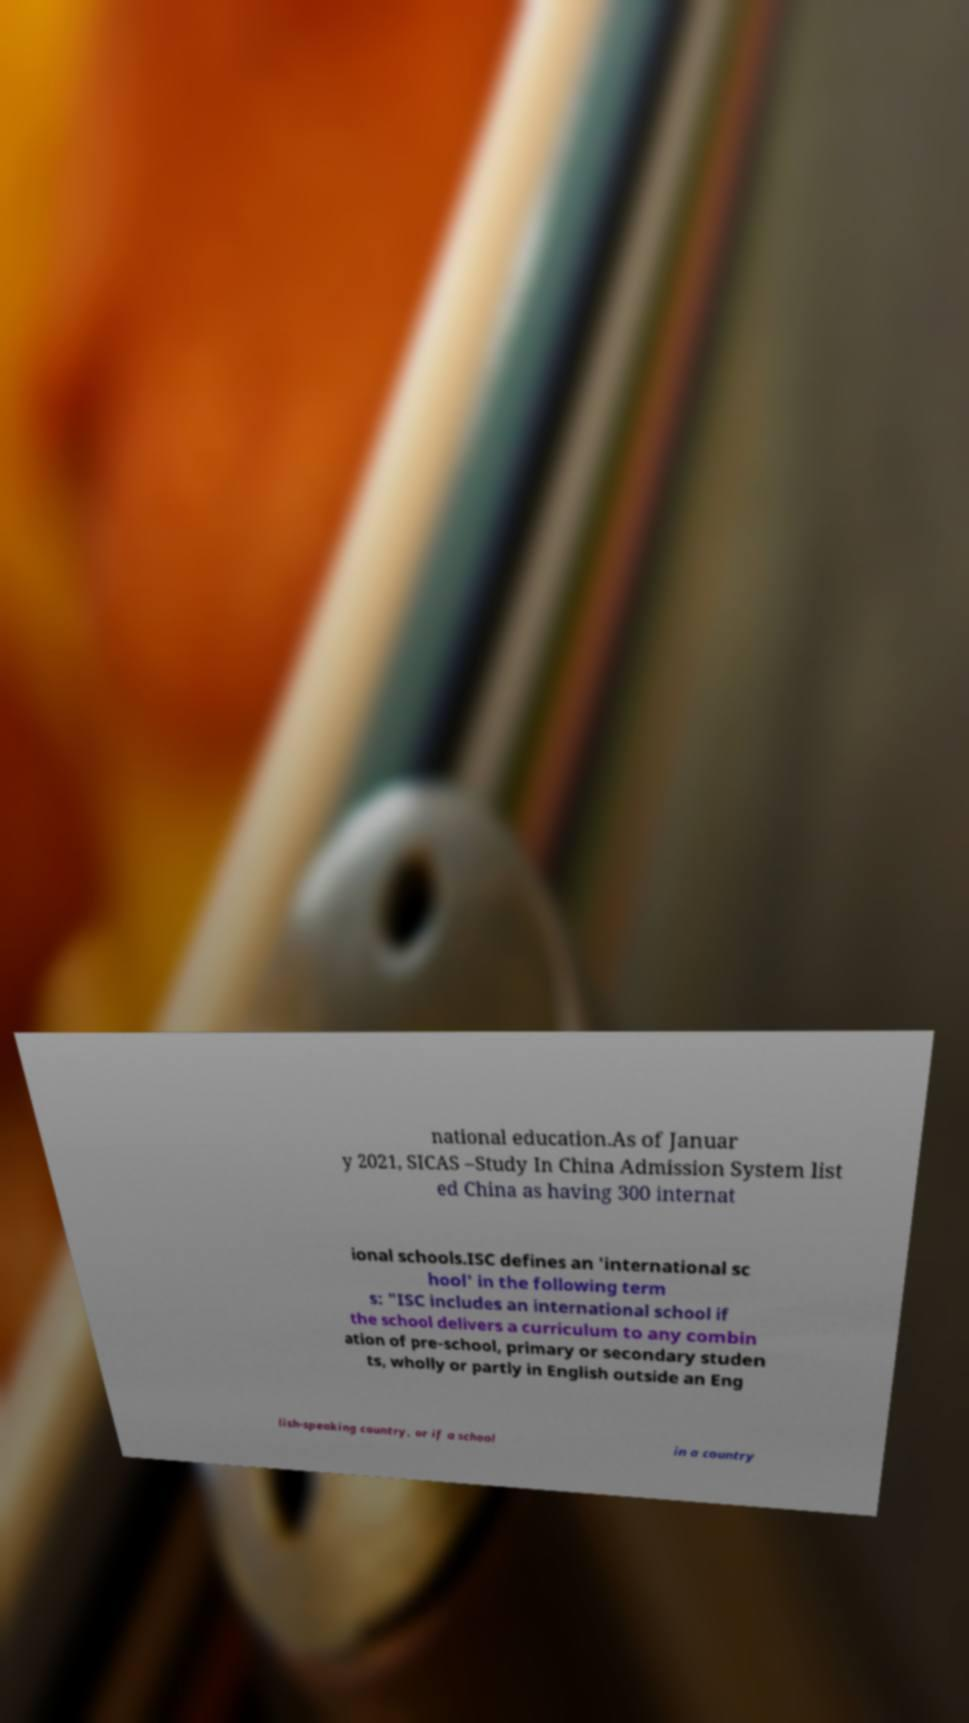Can you accurately transcribe the text from the provided image for me? national education.As of Januar y 2021, SICAS –Study In China Admission System list ed China as having 300 internat ional schools.ISC defines an 'international sc hool' in the following term s: "ISC includes an international school if the school delivers a curriculum to any combin ation of pre-school, primary or secondary studen ts, wholly or partly in English outside an Eng lish-speaking country, or if a school in a country 